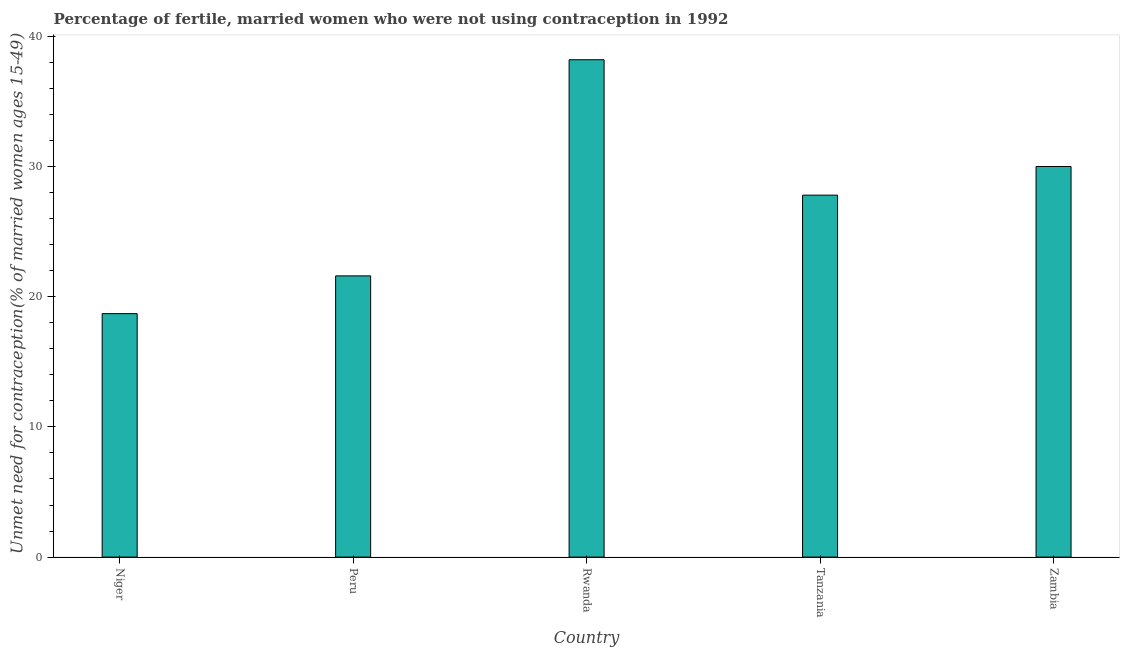Does the graph contain any zero values?
Offer a terse response. No. What is the title of the graph?
Your response must be concise. Percentage of fertile, married women who were not using contraception in 1992. What is the label or title of the X-axis?
Your response must be concise. Country. What is the label or title of the Y-axis?
Make the answer very short.  Unmet need for contraception(% of married women ages 15-49). What is the number of married women who are not using contraception in Niger?
Keep it short and to the point. 18.7. Across all countries, what is the maximum number of married women who are not using contraception?
Offer a terse response. 38.2. Across all countries, what is the minimum number of married women who are not using contraception?
Offer a very short reply. 18.7. In which country was the number of married women who are not using contraception maximum?
Offer a very short reply. Rwanda. In which country was the number of married women who are not using contraception minimum?
Make the answer very short. Niger. What is the sum of the number of married women who are not using contraception?
Ensure brevity in your answer.  136.3. What is the difference between the number of married women who are not using contraception in Niger and Peru?
Keep it short and to the point. -2.9. What is the average number of married women who are not using contraception per country?
Your answer should be compact. 27.26. What is the median number of married women who are not using contraception?
Your answer should be very brief. 27.8. In how many countries, is the number of married women who are not using contraception greater than 34 %?
Offer a very short reply. 1. What is the ratio of the number of married women who are not using contraception in Niger to that in Zambia?
Offer a terse response. 0.62. What is the difference between the highest and the second highest number of married women who are not using contraception?
Give a very brief answer. 8.2. In how many countries, is the number of married women who are not using contraception greater than the average number of married women who are not using contraception taken over all countries?
Keep it short and to the point. 3. How many bars are there?
Keep it short and to the point. 5. Are all the bars in the graph horizontal?
Give a very brief answer. No. What is the difference between two consecutive major ticks on the Y-axis?
Your answer should be very brief. 10. What is the  Unmet need for contraception(% of married women ages 15-49) in Niger?
Provide a short and direct response. 18.7. What is the  Unmet need for contraception(% of married women ages 15-49) of Peru?
Your answer should be compact. 21.6. What is the  Unmet need for contraception(% of married women ages 15-49) of Rwanda?
Keep it short and to the point. 38.2. What is the  Unmet need for contraception(% of married women ages 15-49) of Tanzania?
Keep it short and to the point. 27.8. What is the difference between the  Unmet need for contraception(% of married women ages 15-49) in Niger and Rwanda?
Your answer should be compact. -19.5. What is the difference between the  Unmet need for contraception(% of married women ages 15-49) in Niger and Tanzania?
Offer a very short reply. -9.1. What is the difference between the  Unmet need for contraception(% of married women ages 15-49) in Niger and Zambia?
Ensure brevity in your answer.  -11.3. What is the difference between the  Unmet need for contraception(% of married women ages 15-49) in Peru and Rwanda?
Provide a short and direct response. -16.6. What is the difference between the  Unmet need for contraception(% of married women ages 15-49) in Peru and Tanzania?
Provide a succinct answer. -6.2. What is the difference between the  Unmet need for contraception(% of married women ages 15-49) in Peru and Zambia?
Give a very brief answer. -8.4. What is the difference between the  Unmet need for contraception(% of married women ages 15-49) in Rwanda and Tanzania?
Provide a short and direct response. 10.4. What is the ratio of the  Unmet need for contraception(% of married women ages 15-49) in Niger to that in Peru?
Your answer should be very brief. 0.87. What is the ratio of the  Unmet need for contraception(% of married women ages 15-49) in Niger to that in Rwanda?
Your response must be concise. 0.49. What is the ratio of the  Unmet need for contraception(% of married women ages 15-49) in Niger to that in Tanzania?
Ensure brevity in your answer.  0.67. What is the ratio of the  Unmet need for contraception(% of married women ages 15-49) in Niger to that in Zambia?
Offer a very short reply. 0.62. What is the ratio of the  Unmet need for contraception(% of married women ages 15-49) in Peru to that in Rwanda?
Your answer should be compact. 0.56. What is the ratio of the  Unmet need for contraception(% of married women ages 15-49) in Peru to that in Tanzania?
Provide a succinct answer. 0.78. What is the ratio of the  Unmet need for contraception(% of married women ages 15-49) in Peru to that in Zambia?
Provide a succinct answer. 0.72. What is the ratio of the  Unmet need for contraception(% of married women ages 15-49) in Rwanda to that in Tanzania?
Ensure brevity in your answer.  1.37. What is the ratio of the  Unmet need for contraception(% of married women ages 15-49) in Rwanda to that in Zambia?
Your response must be concise. 1.27. What is the ratio of the  Unmet need for contraception(% of married women ages 15-49) in Tanzania to that in Zambia?
Provide a succinct answer. 0.93. 